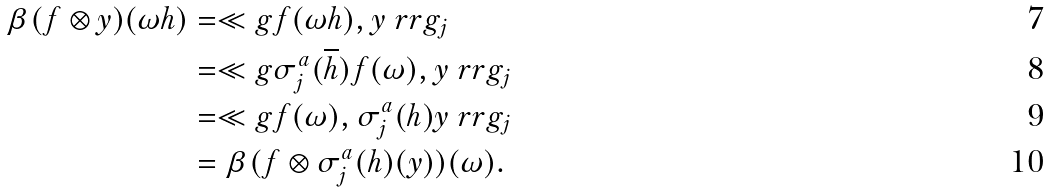<formula> <loc_0><loc_0><loc_500><loc_500>\beta ( f \otimes y ) ( \omega h ) & = \ll g f ( \omega h ) , y \ r r g _ { j } \\ & = \ll g \sigma _ { j } ^ { a } ( \overline { h } ) f ( \omega ) , y \ r r g _ { j } \\ & = \ll g f ( \omega ) , \sigma _ { j } ^ { a } ( h ) y \ r r g _ { j } \\ & = \beta ( f \otimes \sigma _ { j } ^ { a } ( h ) ( y ) ) ( \omega ) .</formula> 